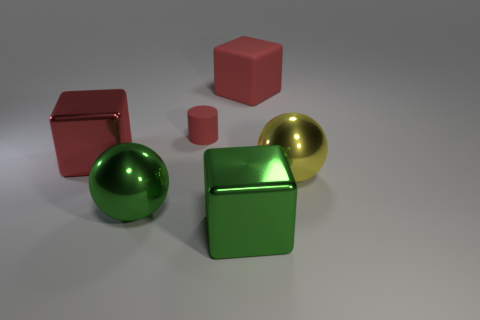Subtract 1 cubes. How many cubes are left? 2 Add 3 big green rubber cylinders. How many objects exist? 9 Subtract all balls. How many objects are left? 4 Add 1 big green spheres. How many big green spheres are left? 2 Add 5 green shiny balls. How many green shiny balls exist? 6 Subtract 0 brown balls. How many objects are left? 6 Subtract all tiny blue cylinders. Subtract all small red cylinders. How many objects are left? 5 